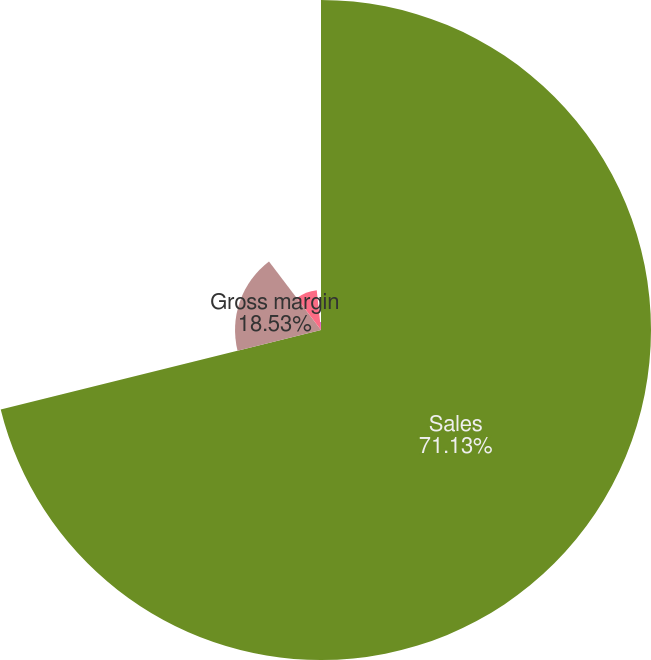<chart> <loc_0><loc_0><loc_500><loc_500><pie_chart><fcel>Sales<fcel>Gross margin<fcel>Canadian resource taxes<fcel>Gross margin (excluding CRT)<nl><fcel>71.13%<fcel>18.53%<fcel>8.64%<fcel>1.7%<nl></chart> 